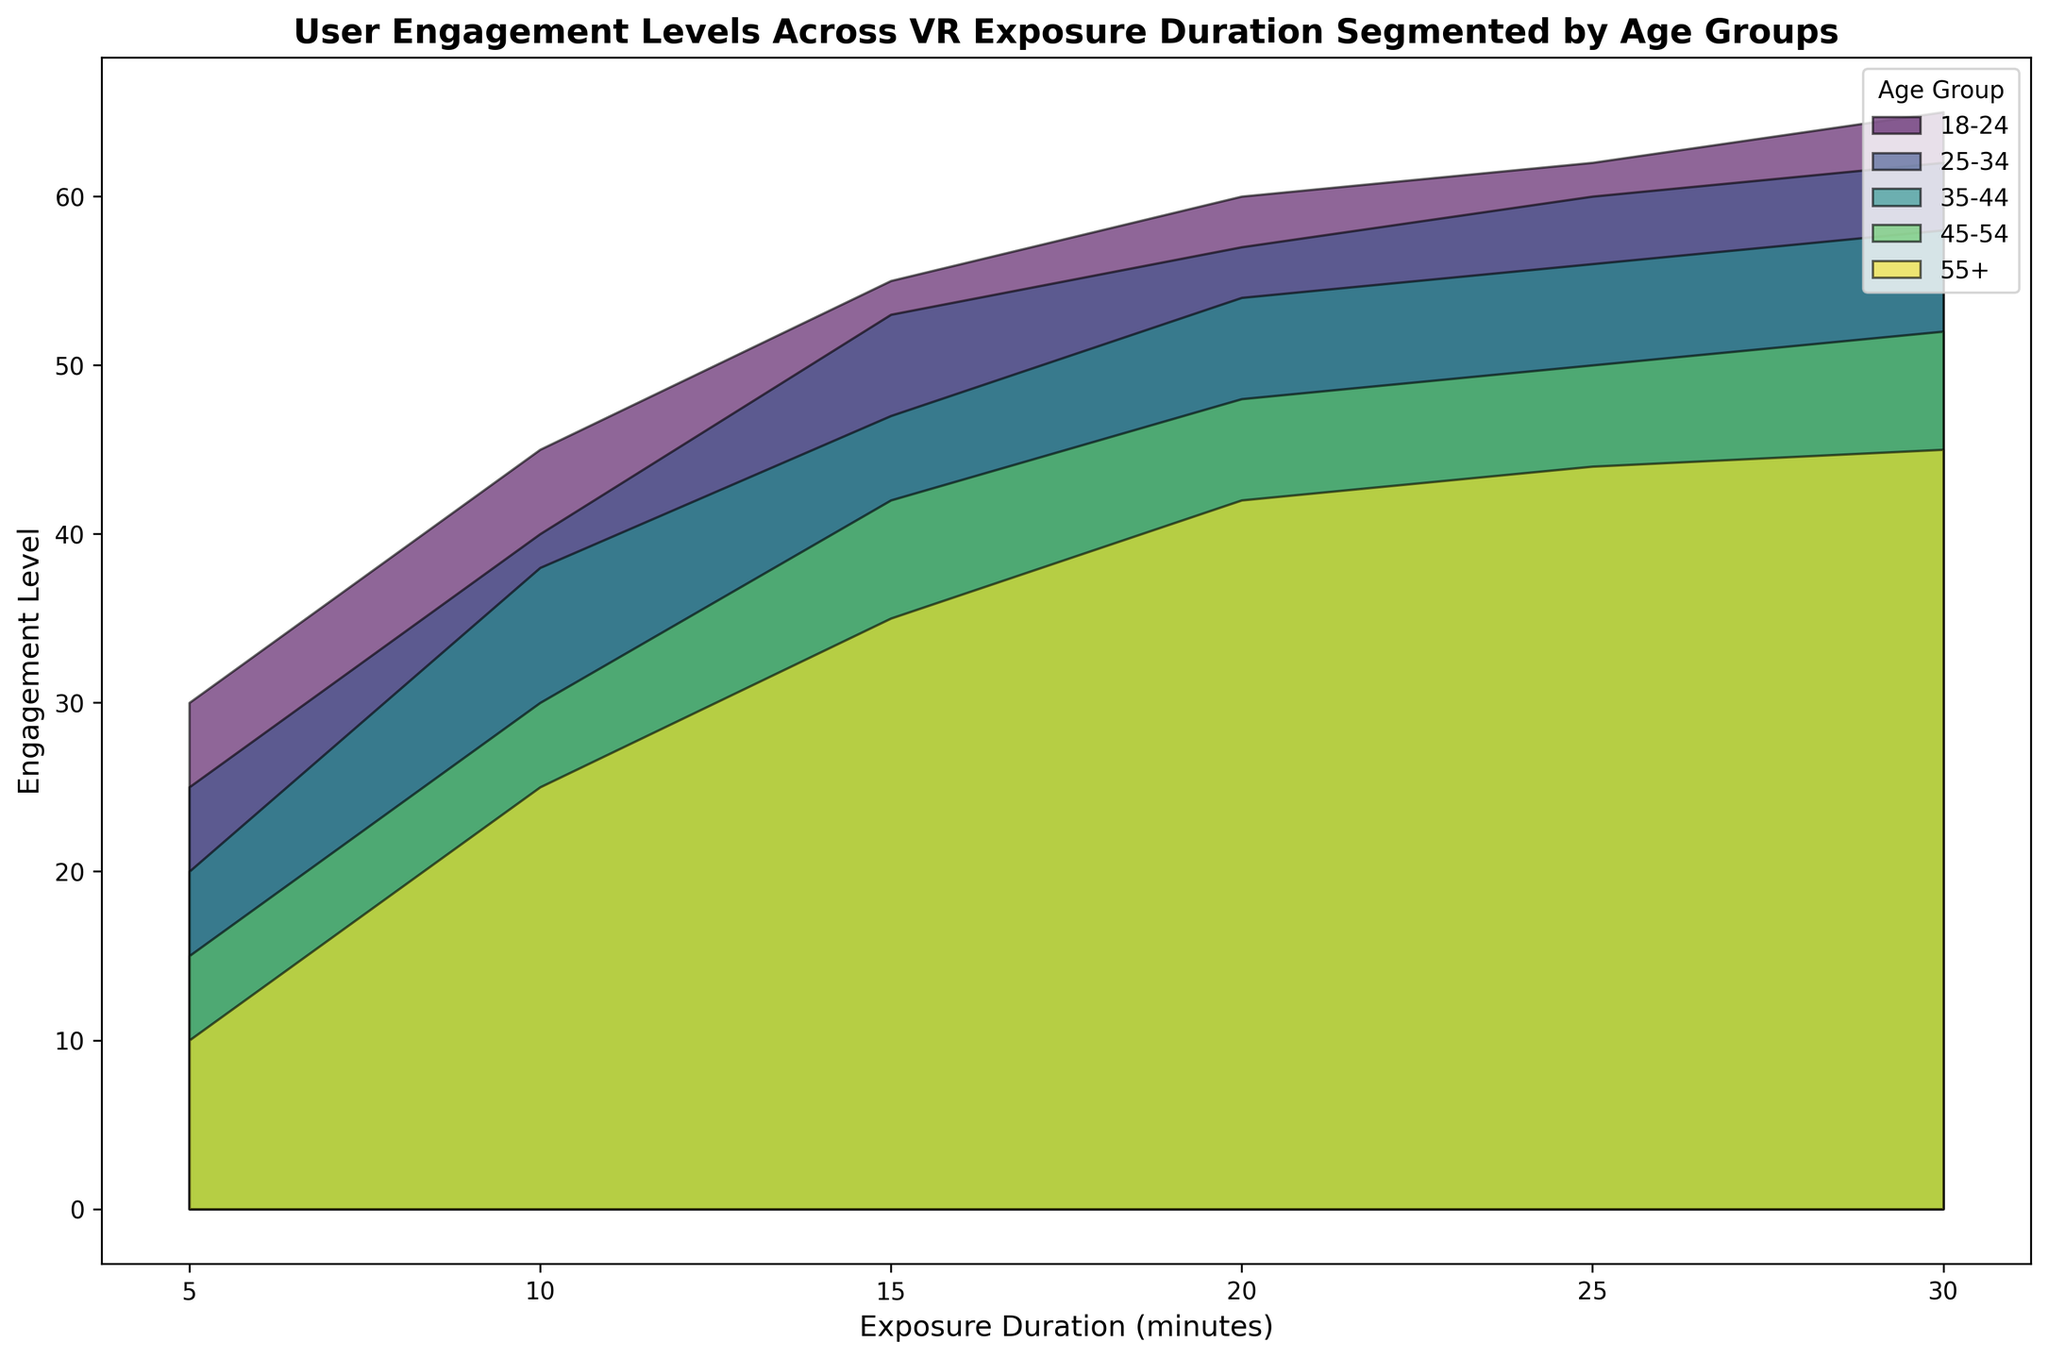What is the engagement level for the 25-34 age group at 10 minutes of exposure duration? Identify the purple area that represents the 25-34 age group, then look at the height at the 10-minute mark on the x-axis.
Answer: 40 Which age group shows the highest engagement level at 30 minutes of exposure duration? Look for the tallest height among the different colored areas at the 30-minute mark on the x-axis. The green area is the highest.
Answer: 18-24 How do the engagement levels of the 35-44 and 45-54 age groups compare at 20 minutes of exposure duration? Locate the 20-minute mark on the x-axis and visually compare the heights of the blue and red areas. The blue area (35-44) is higher than the red area (45-54).
Answer: 35-44 has a higher engagement level What is the difference in engagement levels between the 18-24 and 55+ age groups at 15 minutes? Locate the 15-minute mark on the x-axis and find the heights for the teal (18-24) and purple (55+) regions. Subtract the purple height from the teal height (55 - 35).
Answer: 20 Which age group shows the slowest increase in engagement levels over the entire exposure duration? Examine the slope of the colored areas from left to right. The purple area (55+) shows the smallest increase in height over time.
Answer: 55+ At what exposure duration do 25-34 and 35-44 age groups show approximately the same engagement level? Visually compare the heights of the areas for 25-34 (purple) and 35-44 (blue). They appear to be closest around the 15-minute mark.
Answer: About 15 minutes How do the engagement levels for the 18-24 age group change from 5 to 20 minutes of exposure duration? Look at the teal area and note the engagement levels at 5 minutes (30) and 20 minutes (60). Calculate the difference (60 - 30).
Answer: Increase by 30 What's the combined engagement level of all age groups at 5 minutes? Add the heights of all colored areas at the 5-minute mark: 30 (18-24) + 25 (25-34) + 20 (35-44) + 15 (45-54) + 10 (55+).
Answer: 100 Which age group shows a plateau in engagement level towards the end of the exposure duration? Look for an area that flattens out towards the end. The purple area (55+) levels off between 25 and 30 minutes.
Answer: 55+ At what points do the engagement levels for the 25-34 age group surpass those of the 35-44 age group? Identify where heights of the areas for 25-34 (purple) exceed those of 35-44 (blue). It occurs around the 15-minute mark.
Answer: Around 15 minutes 